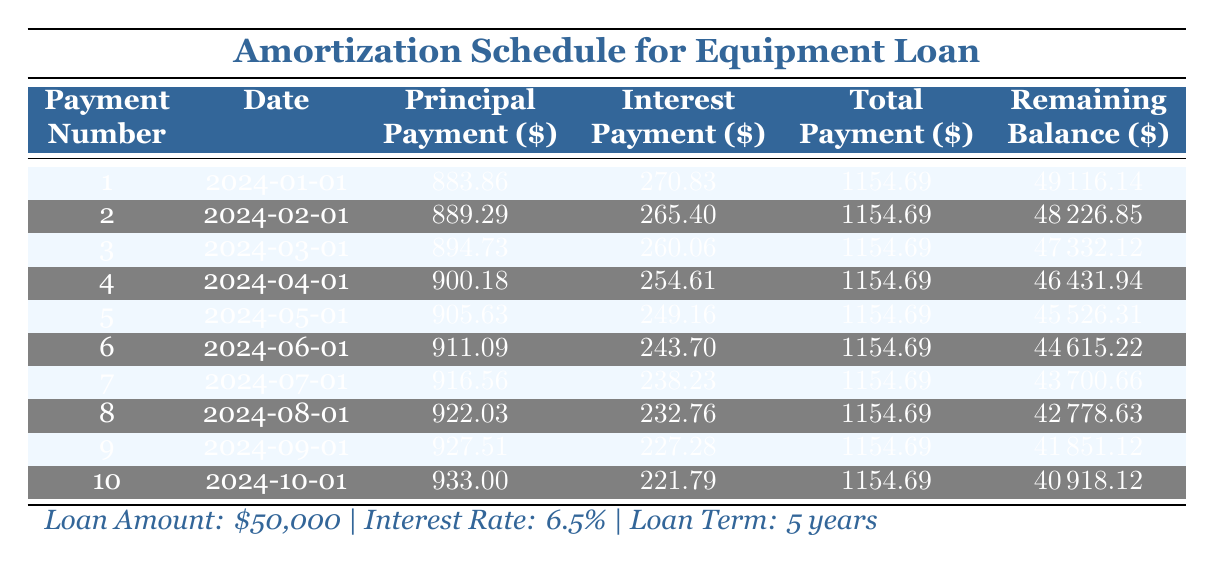What is the monthly payment for the loan? The total monthly payment for each entry in the table is the same, which is 1154.69. This is consistent across all payment periods shown.
Answer: 1154.69 How much principal is paid in the second payment? Referring to the second row of the table, the principal payment for the second payment is specifically listed as 889.29.
Answer: 889.29 What is the total interest paid after the first three payments? To find the total interest paid after three payments, we add the interest payments from the first three rows: 270.83 (first) + 265.40 (second) + 260.06 (third) = 796.29.
Answer: 796.29 Is the interest payment for the first payment higher than the interest payment for the last payment shown in the table? The interest payment for the first payment is 270.83, while the interest payment for the last payment (tenth) is 221.79. Since 270.83 is greater than 221.79, the statement is true.
Answer: Yes What is the remaining balance after the fifth payment? Looking at the fifth row, the remaining balance after the fifth payment is clearly stated as 45526.31.
Answer: 45526.31 What is the average principal payment over the first ten payments? To find the average principal payment, we calculate the total principal payment by adding the values from the first ten payments: (883.86 + 889.29 + 894.73 + 900.18 + 905.63 + 911.09 + 916.56 + 922.03 + 927.51 + 933.00) = 9114.88. Then divide by ten payments to find the average: 9114.88 / 10 = 911.49.
Answer: 911.49 What is the total amount paid towards principal after six payments? First, we sum the principal payments from the first six rows: 883.86 + 889.29 + 894.73 + 900.18 + 905.63 + 911.09 = 4884.78. This gives the total principal amount paid after the sixth payment.
Answer: 4884.78 If the interest rate was reduced to 5%, would the monthly payment increase or decrease? Changing the interest rate from 6.5% to 5% typically results in a lower monthly payment, as lower interest decreases the cost of borrowing. Therefore, the monthly payment would decrease.
Answer: Decrease 